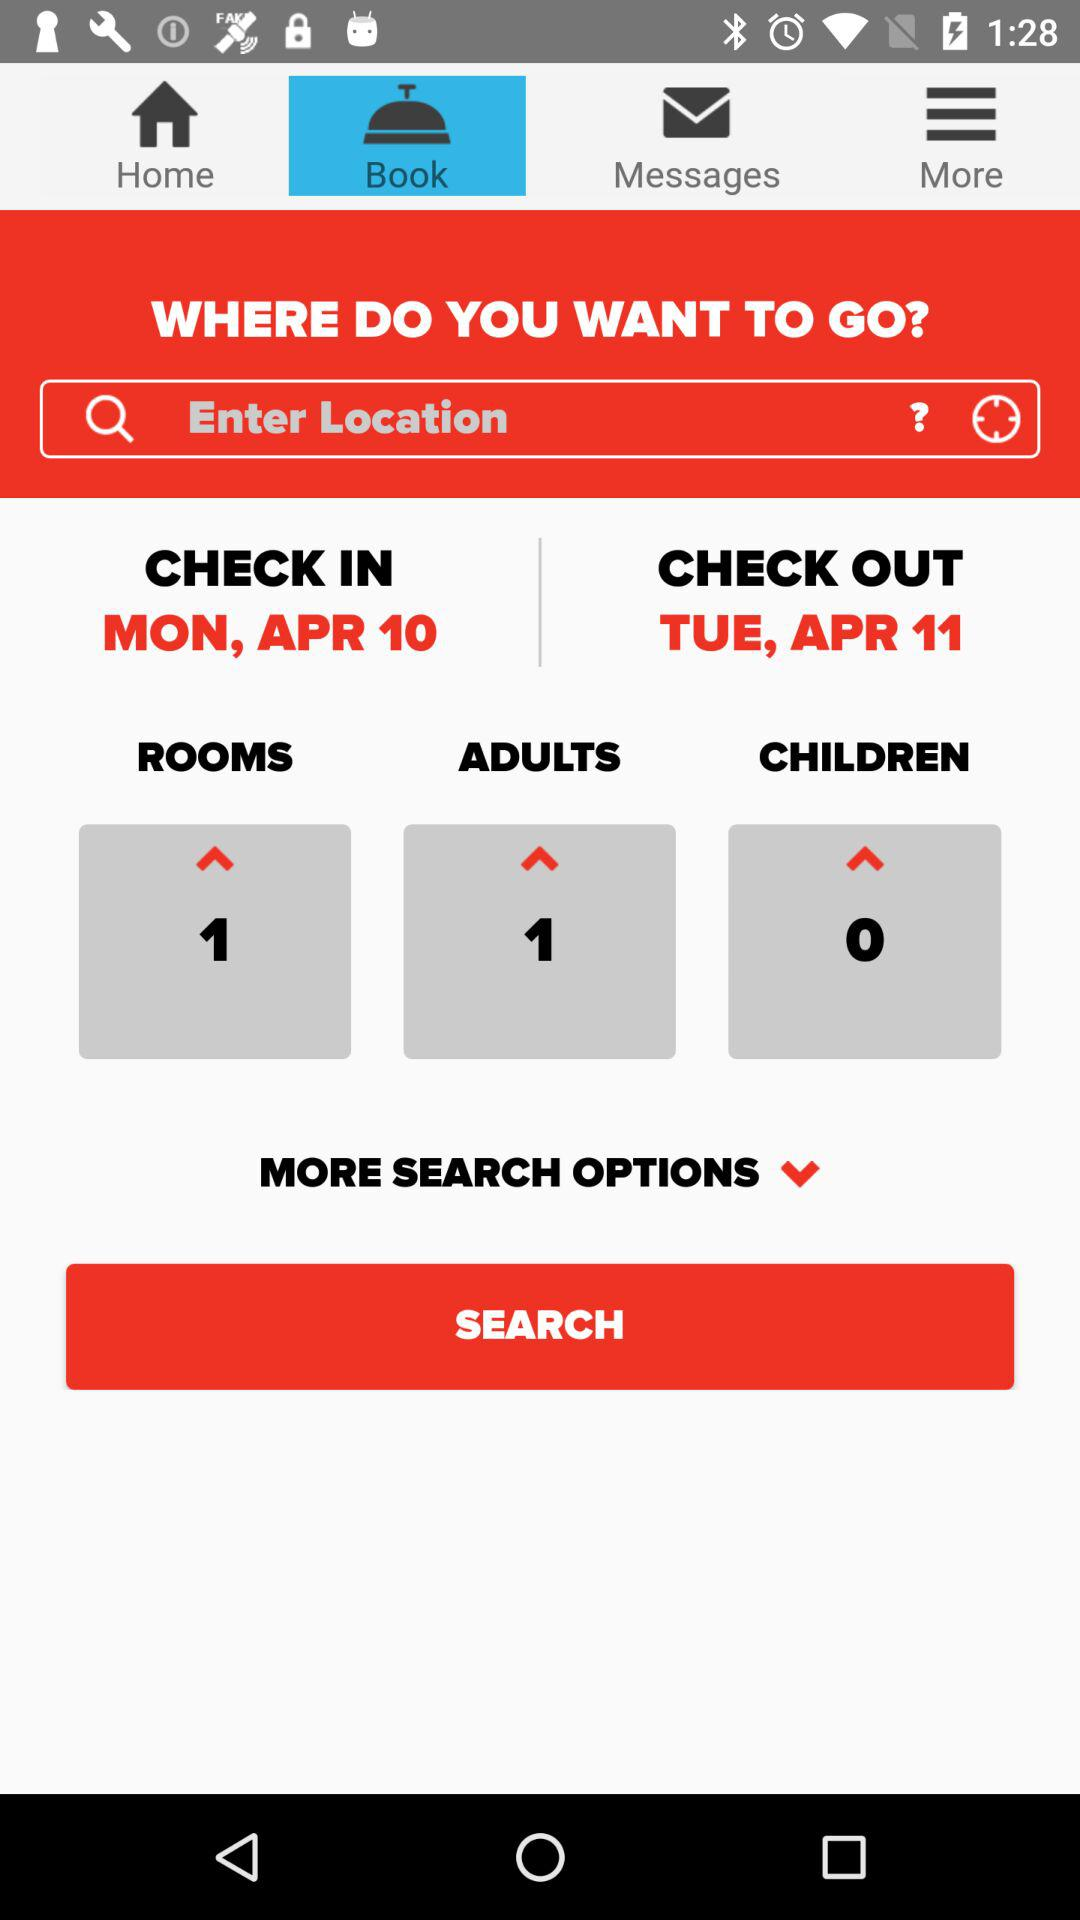What is the check-in date? The check-in date is Monday, April 10. 